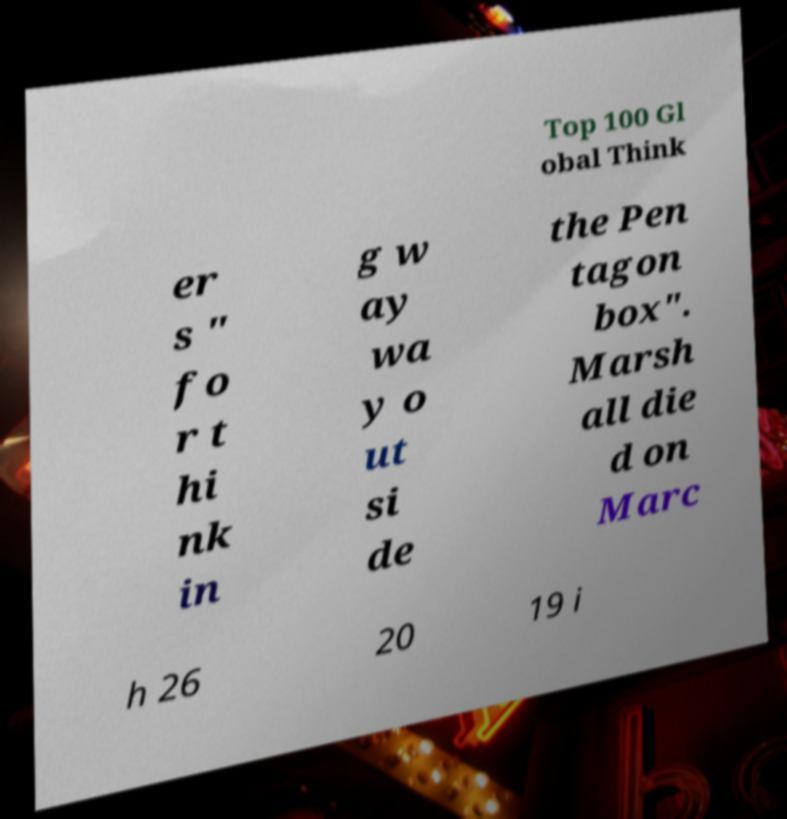There's text embedded in this image that I need extracted. Can you transcribe it verbatim? Top 100 Gl obal Think er s " fo r t hi nk in g w ay wa y o ut si de the Pen tagon box". Marsh all die d on Marc h 26 20 19 i 